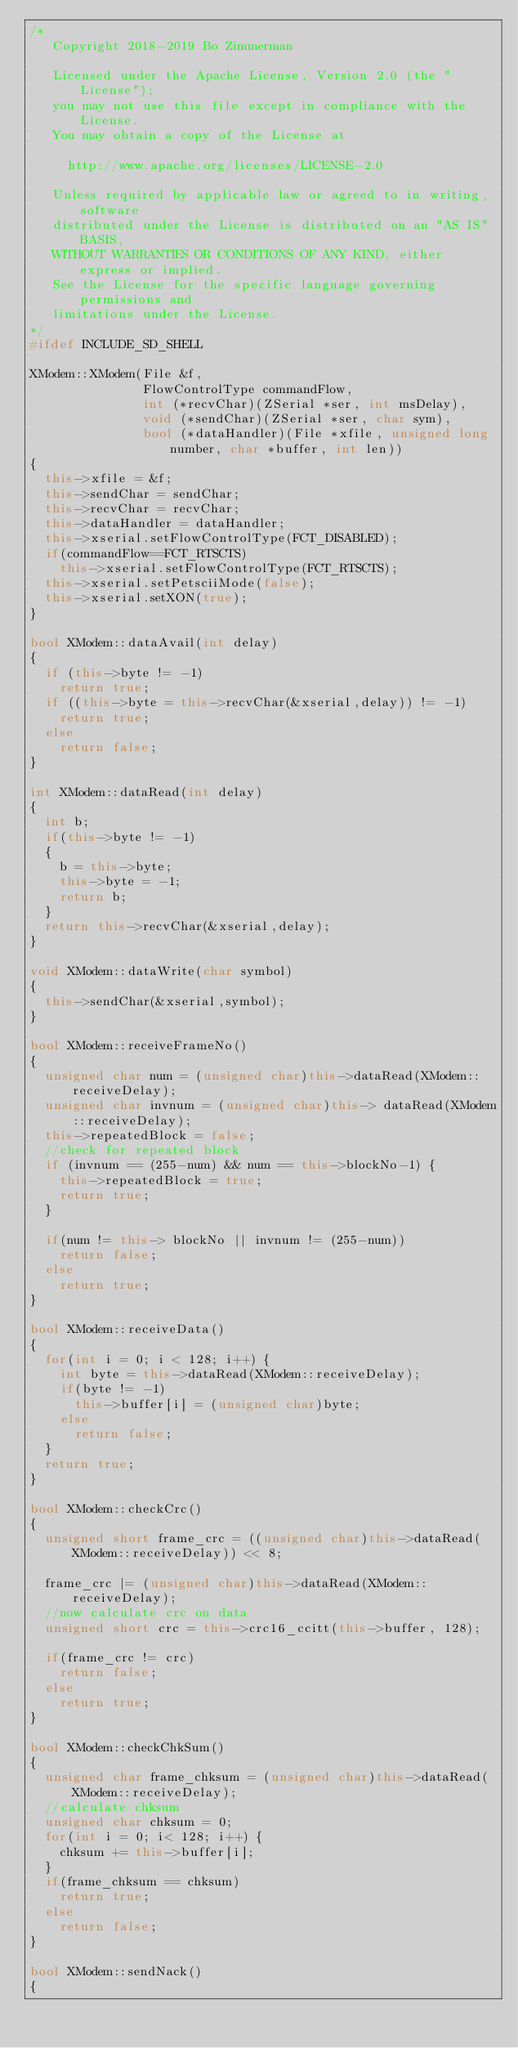<code> <loc_0><loc_0><loc_500><loc_500><_C++_>/*
   Copyright 2018-2019 Bo Zimmerman

   Licensed under the Apache License, Version 2.0 (the "License");
   you may not use this file except in compliance with the License.
   You may obtain a copy of the License at

     http://www.apache.org/licenses/LICENSE-2.0

   Unless required by applicable law or agreed to in writing, software
   distributed under the License is distributed on an "AS IS" BASIS,
   WITHOUT WARRANTIES OR CONDITIONS OF ANY KIND, either express or implied.
   See the License for the specific language governing permissions and
   limitations under the License.
*/
#ifdef INCLUDE_SD_SHELL

XModem::XModem(File &f,
               FlowControlType commandFlow, 
               int (*recvChar)(ZSerial *ser, int msDelay), 
               void (*sendChar)(ZSerial *ser, char sym), 
               bool (*dataHandler)(File *xfile, unsigned long number, char *buffer, int len))
{
  this->xfile = &f;
  this->sendChar = sendChar;
  this->recvChar = recvChar;
  this->dataHandler = dataHandler;  
  this->xserial.setFlowControlType(FCT_DISABLED);
  if(commandFlow==FCT_RTSCTS)
    this->xserial.setFlowControlType(FCT_RTSCTS);
  this->xserial.setPetsciiMode(false);
  this->xserial.setXON(true);
}

bool XModem::dataAvail(int delay)
{
  if (this->byte != -1)
    return true;
  if ((this->byte = this->recvChar(&xserial,delay)) != -1)
    return true;
  else
    return false;    
}

int XModem::dataRead(int delay)
{
  int b;
  if(this->byte != -1)
  {
    b = this->byte;
    this->byte = -1;
    return b;
  }
  return this->recvChar(&xserial,delay);
}

void XModem::dataWrite(char symbol)
{
  this->sendChar(&xserial,symbol);
}

bool XModem::receiveFrameNo()
{
  unsigned char num = (unsigned char)this->dataRead(XModem::receiveDelay);
  unsigned char invnum = (unsigned char)this-> dataRead(XModem::receiveDelay);
  this->repeatedBlock = false;
  //check for repeated block
  if (invnum == (255-num) && num == this->blockNo-1) {
    this->repeatedBlock = true;
    return true;  
  }
  
  if(num != this-> blockNo || invnum != (255-num))
    return false;
  else
    return true;
}

bool XModem::receiveData()
{
  for(int i = 0; i < 128; i++) {
    int byte = this->dataRead(XModem::receiveDelay);
    if(byte != -1)
      this->buffer[i] = (unsigned char)byte;
    else
      return false;
  }
  return true;  
}

bool XModem::checkCrc()
{
  unsigned short frame_crc = ((unsigned char)this->dataRead(XModem::receiveDelay)) << 8;
  
  frame_crc |= (unsigned char)this->dataRead(XModem::receiveDelay);
  //now calculate crc on data
  unsigned short crc = this->crc16_ccitt(this->buffer, 128);
  
  if(frame_crc != crc)
    return false;
  else
    return true;  
}

bool XModem::checkChkSum()
{
  unsigned char frame_chksum = (unsigned char)this->dataRead(XModem::receiveDelay);
  //calculate chksum
  unsigned char chksum = 0;
  for(int i = 0; i< 128; i++) {
    chksum += this->buffer[i];
  }
  if(frame_chksum == chksum)
    return true;
  else
    return false;
}

bool XModem::sendNack()
{</code> 